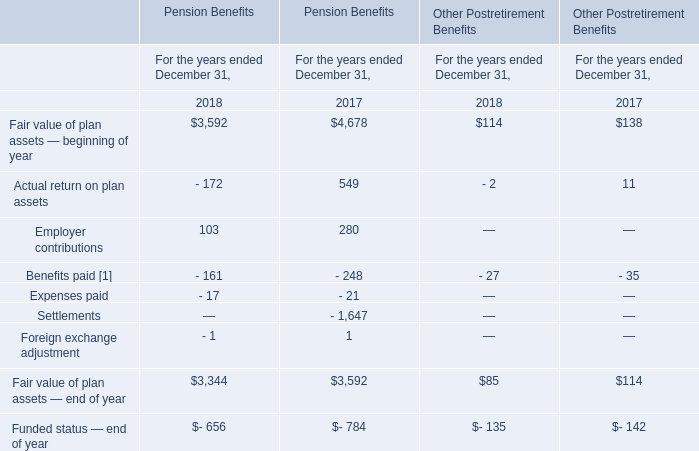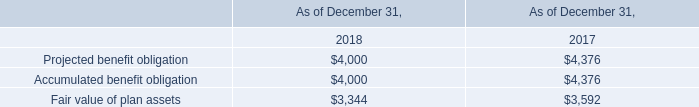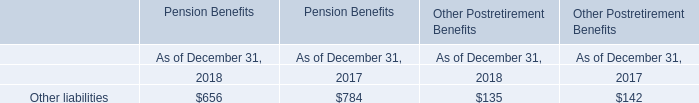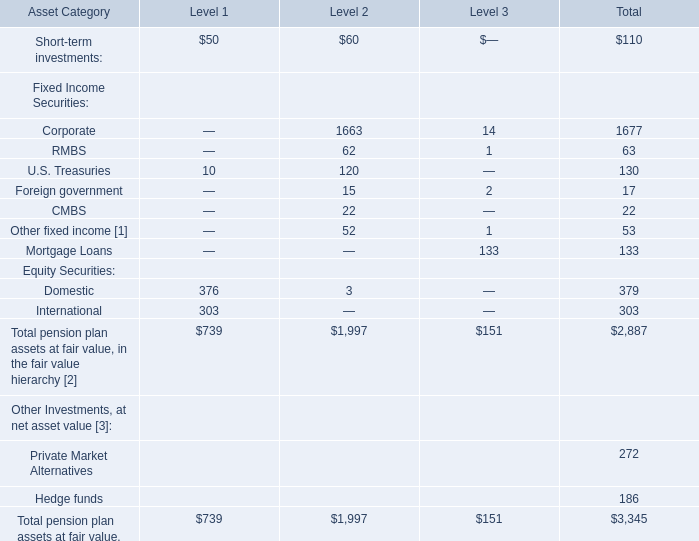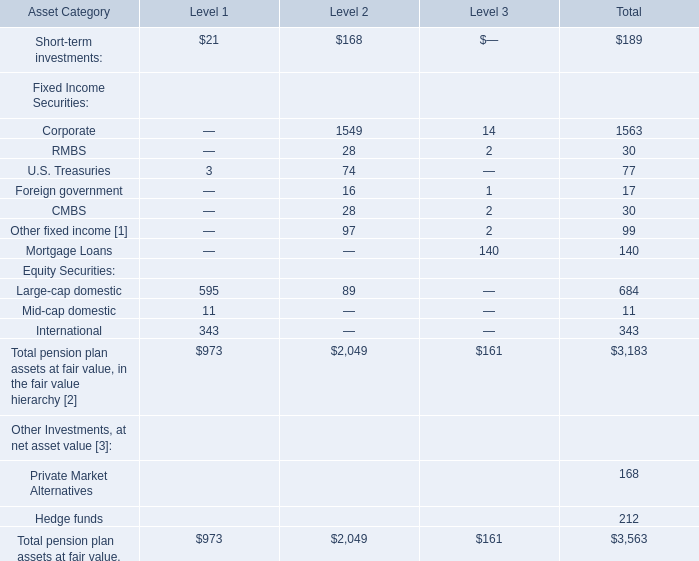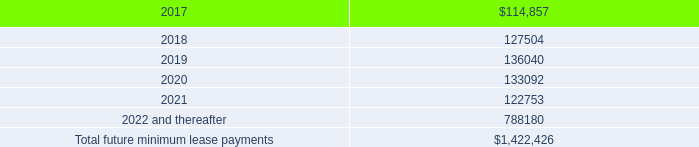what percentage change in rent expense from 2015 to 2016? 
Computations: ((109.0 - 83.0) / 83.0)
Answer: 0.31325. 